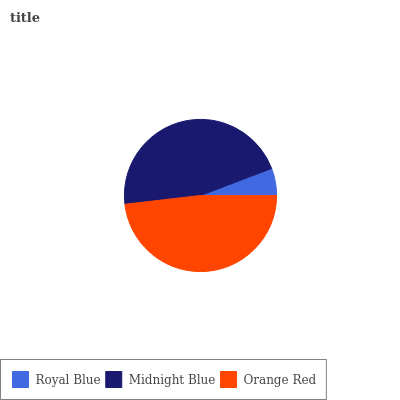Is Royal Blue the minimum?
Answer yes or no. Yes. Is Orange Red the maximum?
Answer yes or no. Yes. Is Midnight Blue the minimum?
Answer yes or no. No. Is Midnight Blue the maximum?
Answer yes or no. No. Is Midnight Blue greater than Royal Blue?
Answer yes or no. Yes. Is Royal Blue less than Midnight Blue?
Answer yes or no. Yes. Is Royal Blue greater than Midnight Blue?
Answer yes or no. No. Is Midnight Blue less than Royal Blue?
Answer yes or no. No. Is Midnight Blue the high median?
Answer yes or no. Yes. Is Midnight Blue the low median?
Answer yes or no. Yes. Is Orange Red the high median?
Answer yes or no. No. Is Orange Red the low median?
Answer yes or no. No. 